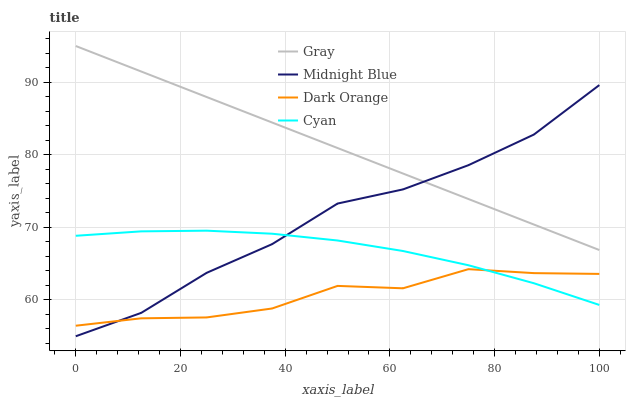Does Dark Orange have the minimum area under the curve?
Answer yes or no. Yes. Does Gray have the maximum area under the curve?
Answer yes or no. Yes. Does Cyan have the minimum area under the curve?
Answer yes or no. No. Does Cyan have the maximum area under the curve?
Answer yes or no. No. Is Gray the smoothest?
Answer yes or no. Yes. Is Midnight Blue the roughest?
Answer yes or no. Yes. Is Cyan the smoothest?
Answer yes or no. No. Is Cyan the roughest?
Answer yes or no. No. Does Midnight Blue have the lowest value?
Answer yes or no. Yes. Does Cyan have the lowest value?
Answer yes or no. No. Does Gray have the highest value?
Answer yes or no. Yes. Does Cyan have the highest value?
Answer yes or no. No. Is Dark Orange less than Gray?
Answer yes or no. Yes. Is Gray greater than Dark Orange?
Answer yes or no. Yes. Does Cyan intersect Dark Orange?
Answer yes or no. Yes. Is Cyan less than Dark Orange?
Answer yes or no. No. Is Cyan greater than Dark Orange?
Answer yes or no. No. Does Dark Orange intersect Gray?
Answer yes or no. No. 